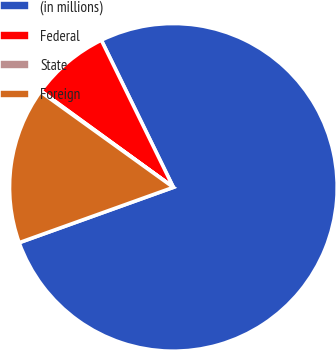Convert chart. <chart><loc_0><loc_0><loc_500><loc_500><pie_chart><fcel>(in millions)<fcel>Federal<fcel>State<fcel>Foreign<nl><fcel>76.76%<fcel>7.75%<fcel>0.08%<fcel>15.41%<nl></chart> 